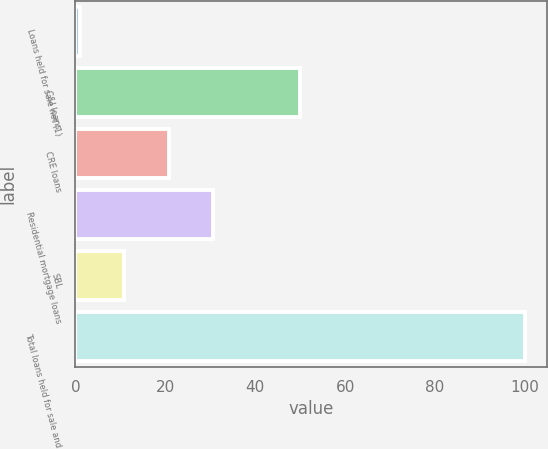Convert chart to OTSL. <chart><loc_0><loc_0><loc_500><loc_500><bar_chart><fcel>Loans held for sale net (1)<fcel>C&I loans<fcel>CRE loans<fcel>Residential mortgage loans<fcel>SBL<fcel>Total loans held for sale and<nl><fcel>1<fcel>50<fcel>20.8<fcel>30.7<fcel>10.9<fcel>100<nl></chart> 